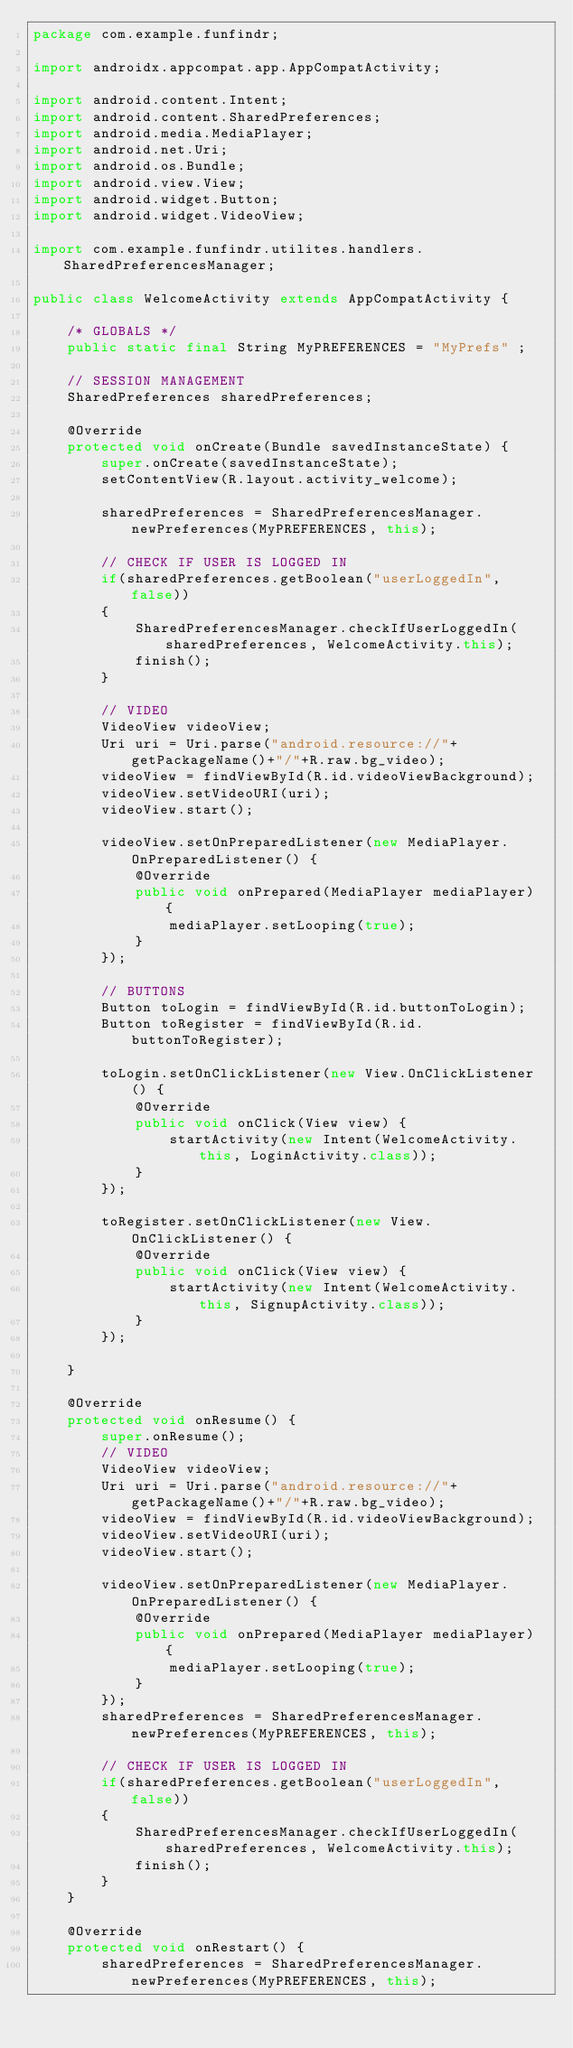<code> <loc_0><loc_0><loc_500><loc_500><_Java_>package com.example.funfindr;

import androidx.appcompat.app.AppCompatActivity;

import android.content.Intent;
import android.content.SharedPreferences;
import android.media.MediaPlayer;
import android.net.Uri;
import android.os.Bundle;
import android.view.View;
import android.widget.Button;
import android.widget.VideoView;

import com.example.funfindr.utilites.handlers.SharedPreferencesManager;

public class WelcomeActivity extends AppCompatActivity {

    /* GLOBALS */
    public static final String MyPREFERENCES = "MyPrefs" ;

    // SESSION MANAGEMENT
    SharedPreferences sharedPreferences;

    @Override
    protected void onCreate(Bundle savedInstanceState) {
        super.onCreate(savedInstanceState);
        setContentView(R.layout.activity_welcome);

        sharedPreferences = SharedPreferencesManager.newPreferences(MyPREFERENCES, this);

        // CHECK IF USER IS LOGGED IN
        if(sharedPreferences.getBoolean("userLoggedIn", false))
        {
            SharedPreferencesManager.checkIfUserLoggedIn(sharedPreferences, WelcomeActivity.this);
            finish();
        }

        // VIDEO
        VideoView videoView;
        Uri uri = Uri.parse("android.resource://"+getPackageName()+"/"+R.raw.bg_video);
        videoView = findViewById(R.id.videoViewBackground);
        videoView.setVideoURI(uri);
        videoView.start();

        videoView.setOnPreparedListener(new MediaPlayer.OnPreparedListener() {
            @Override
            public void onPrepared(MediaPlayer mediaPlayer) {
                mediaPlayer.setLooping(true);
            }
        });

        // BUTTONS
        Button toLogin = findViewById(R.id.buttonToLogin);
        Button toRegister = findViewById(R.id.buttonToRegister);

        toLogin.setOnClickListener(new View.OnClickListener() {
            @Override
            public void onClick(View view) {
                startActivity(new Intent(WelcomeActivity.this, LoginActivity.class));
            }
        });

        toRegister.setOnClickListener(new View.OnClickListener() {
            @Override
            public void onClick(View view) {
                startActivity(new Intent(WelcomeActivity.this, SignupActivity.class));
            }
        });

    }

    @Override
    protected void onResume() {
        super.onResume();
        // VIDEO
        VideoView videoView;
        Uri uri = Uri.parse("android.resource://"+getPackageName()+"/"+R.raw.bg_video);
        videoView = findViewById(R.id.videoViewBackground);
        videoView.setVideoURI(uri);
        videoView.start();

        videoView.setOnPreparedListener(new MediaPlayer.OnPreparedListener() {
            @Override
            public void onPrepared(MediaPlayer mediaPlayer) {
                mediaPlayer.setLooping(true);
            }
        });
        sharedPreferences = SharedPreferencesManager.newPreferences(MyPREFERENCES, this);

        // CHECK IF USER IS LOGGED IN
        if(sharedPreferences.getBoolean("userLoggedIn", false))
        {
            SharedPreferencesManager.checkIfUserLoggedIn(sharedPreferences, WelcomeActivity.this);
            finish();
        }
    }

    @Override
    protected void onRestart() {
        sharedPreferences = SharedPreferencesManager.newPreferences(MyPREFERENCES, this);
</code> 